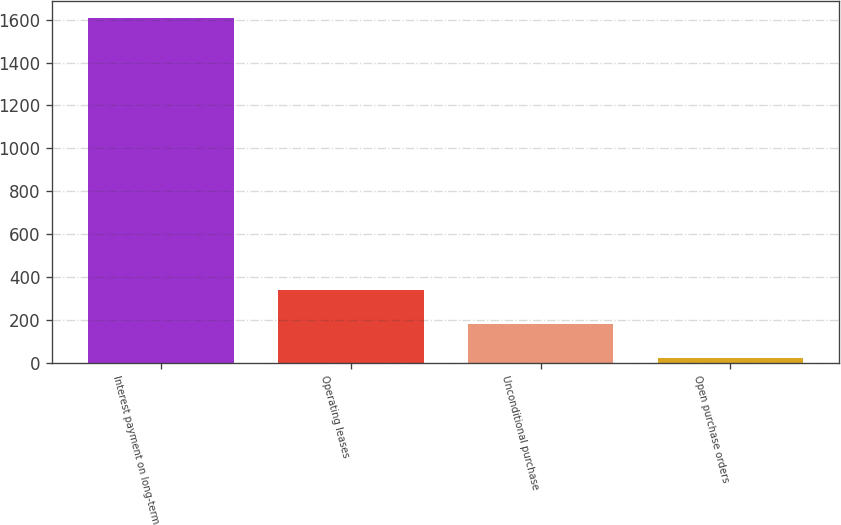<chart> <loc_0><loc_0><loc_500><loc_500><bar_chart><fcel>Interest payment on long-term<fcel>Operating leases<fcel>Unconditional purchase<fcel>Open purchase orders<nl><fcel>1608<fcel>340<fcel>181.5<fcel>23<nl></chart> 